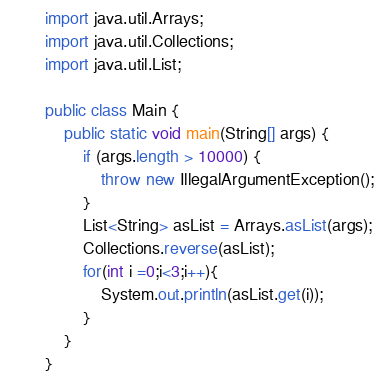<code> <loc_0><loc_0><loc_500><loc_500><_Java_>
import java.util.Arrays;
import java.util.Collections;
import java.util.List;

public class Main {
	public static void main(String[] args) {
		if (args.length > 10000) {
			throw new IllegalArgumentException();
		}
		List<String> asList = Arrays.asList(args);
		Collections.reverse(asList);
		for(int i =0;i<3;i++){
			System.out.println(asList.get(i));
		}
	}
}</code> 